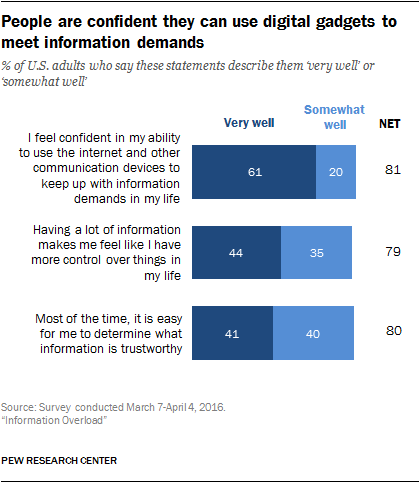Give some essential details in this illustration. I will add all the bars whose value exceeds 40. The value of the first "Very well" bar from the bottom is 41. 